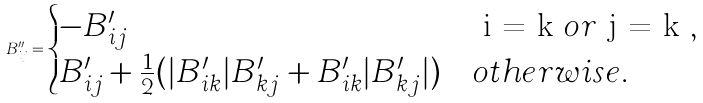<formula> <loc_0><loc_0><loc_500><loc_500>B ^ { \prime \prime } _ { i j } = \begin{cases} - B ^ { \prime } _ { i j } & $ i = k $ o r $ j = k $ , \\ B ^ { \prime } _ { i j } + \frac { 1 } { 2 } ( | B ^ { \prime } _ { i k } | B ^ { \prime } _ { k j } + B ^ { \prime } _ { i k } | B ^ { \prime } _ { k j } | ) & o t h e r w i s e . \end{cases}</formula> 